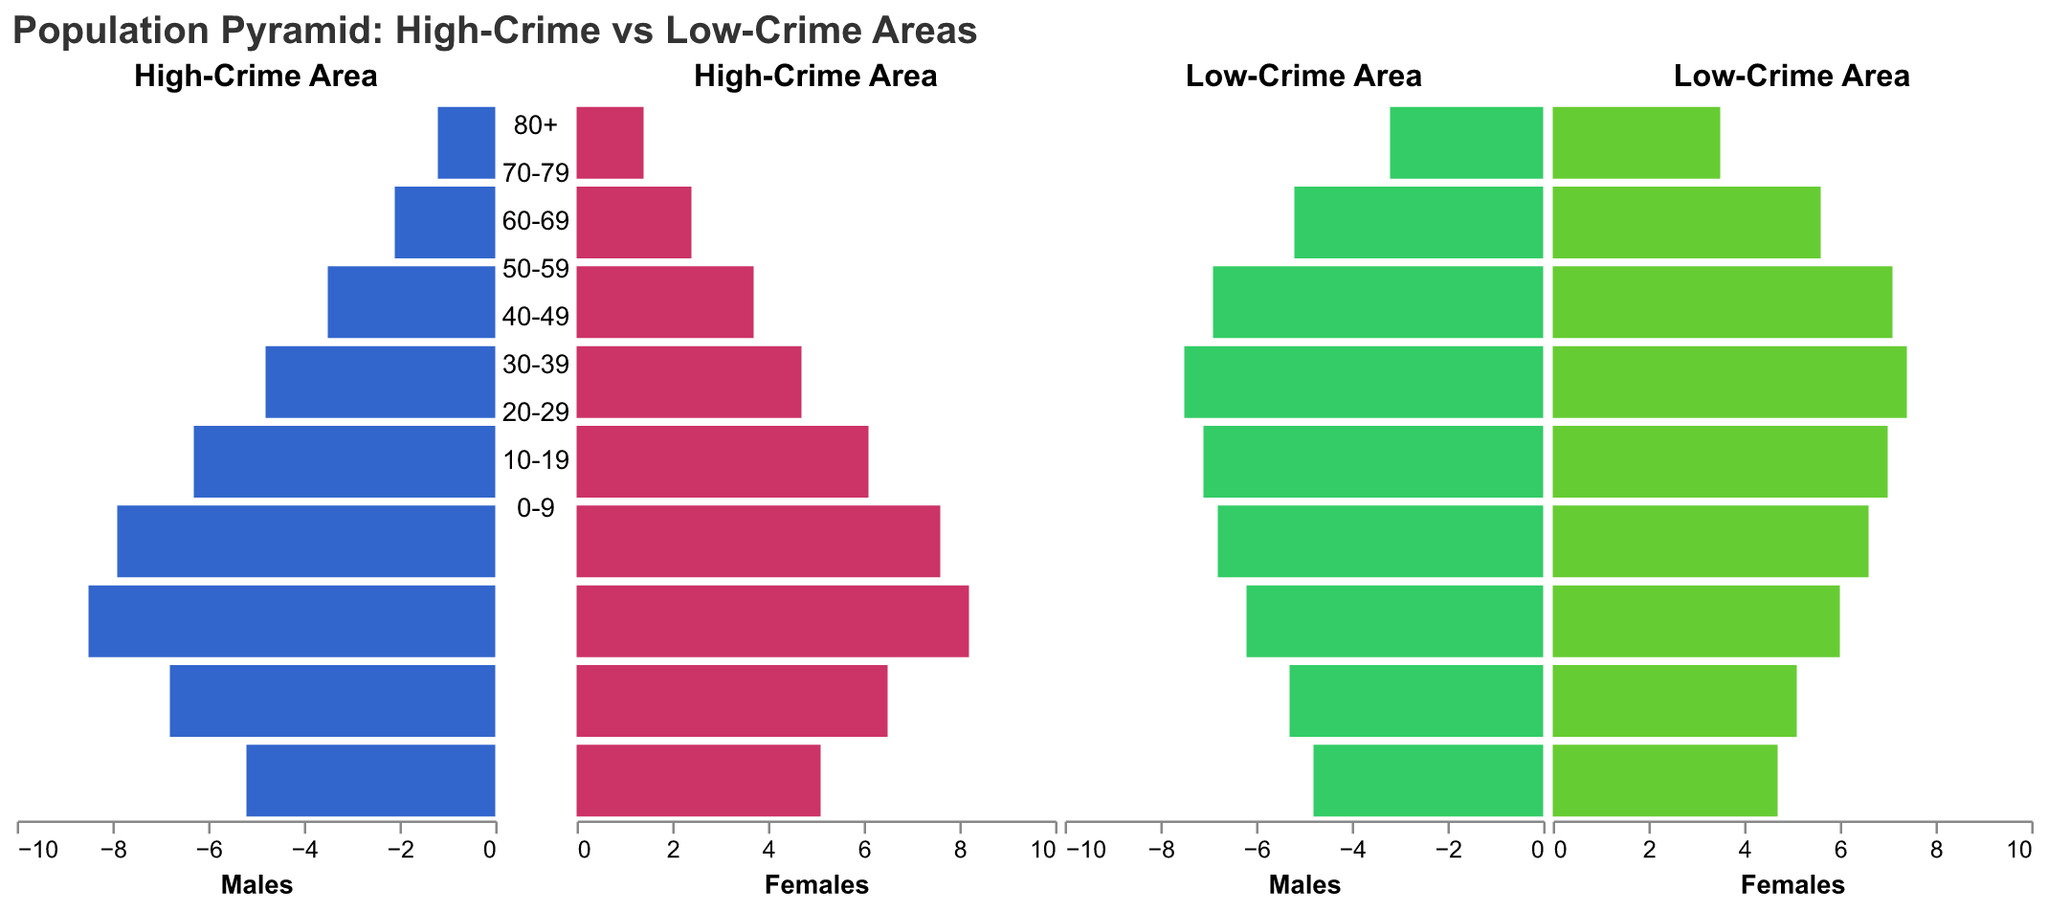What age group has the highest percentage of males in high-crime areas? The age group 20-29 has the highest percentage of males in high-crime areas as we can refer to the bar length in the population pyramid, which is the longest for this age group among males.
Answer: 20-29 Which area has a higher percentage of females aged 40-49, high-crime or low-crime areas? For the age group 40-49, the low-crime area bar for females is longer than that of the high-crime area.
Answer: Low-crime How does the percentage of males aged 50-59 compare between high-crime and low-crime areas? The bar length for males aged 50-59 is longer in low-crime areas compared to high-crime areas, indicating a higher percentage in low-crime areas.
Answer: Lower in high-crime What is the overall trend for the percentage of residents aged 80+ in both high-crime and low-crime areas? The population pyramid shows shorter bars for both genders aged 80+ in high-crime areas compared to low-crime areas, indicating a lower percentage of this age group in high-crime areas.
Answer: Higher in low-crime Comparing the age group 30-39, where do we see a larger difference between male and female percentages in high-crime areas or low-crime areas? In high-crime areas, the difference between male (7.9) and female (7.6) percentages in the 30-39 age group is 0.3, whereas in low-crime areas, it's 0.2 (6.8 for males and 6.6 for females). Thus, the difference is larger in high-crime areas.
Answer: High-crime areas What is the most significant difference in female population percentages between the high-crime and low-crime areas for any age group? The most significant difference is in the age group 50-59, where the low-crime area has 7.4% females compared to 4.7% in the high-crime area, a difference of 2.7%.
Answer: Age group 50-59 How does the percentage of children aged 0-9 compare between high-crime and low-crime areas? Children aged 0-9 have a slightly higher percentage in high-crime areas (5.2% males, 5.1% females) compared to low-crime areas (4.8% males, 4.7% females).
Answer: Higher in high-crime For the age group 10-19, in which area do we have more males and what is the percentage difference? The percentage of males aged 10-19 is higher in high-crime areas (6.8%) compared to low-crime areas (5.3%), with a difference of 1.5%.
Answer: High-crime areas, 1.5% 